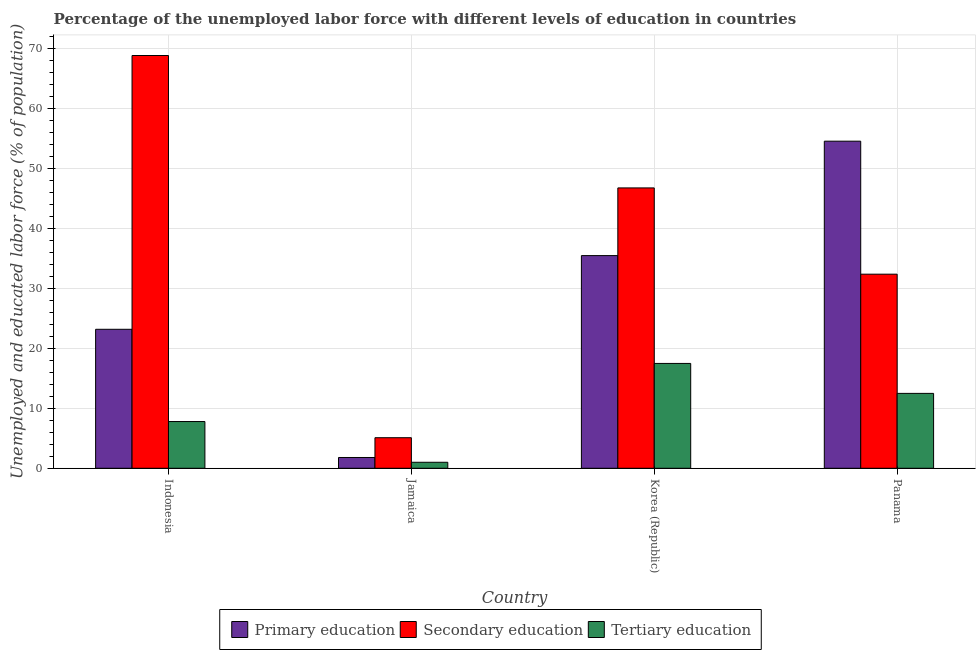How many groups of bars are there?
Offer a very short reply. 4. What is the label of the 2nd group of bars from the left?
Offer a terse response. Jamaica. In how many cases, is the number of bars for a given country not equal to the number of legend labels?
Your answer should be very brief. 0. What is the percentage of labor force who received tertiary education in Panama?
Your answer should be compact. 12.5. Across all countries, what is the minimum percentage of labor force who received primary education?
Offer a terse response. 1.8. In which country was the percentage of labor force who received primary education minimum?
Your response must be concise. Jamaica. What is the total percentage of labor force who received primary education in the graph?
Offer a terse response. 115.1. What is the difference between the percentage of labor force who received secondary education in Jamaica and that in Korea (Republic)?
Provide a succinct answer. -41.7. What is the difference between the percentage of labor force who received tertiary education in Indonesia and the percentage of labor force who received primary education in Panama?
Keep it short and to the point. -46.8. What is the average percentage of labor force who received primary education per country?
Offer a very short reply. 28.77. What is the difference between the percentage of labor force who received secondary education and percentage of labor force who received primary education in Korea (Republic)?
Provide a succinct answer. 11.3. What is the ratio of the percentage of labor force who received secondary education in Indonesia to that in Korea (Republic)?
Make the answer very short. 1.47. Is the percentage of labor force who received primary education in Jamaica less than that in Panama?
Your answer should be very brief. Yes. What is the difference between the highest and the second highest percentage of labor force who received secondary education?
Make the answer very short. 22.1. What is the difference between the highest and the lowest percentage of labor force who received primary education?
Make the answer very short. 52.8. In how many countries, is the percentage of labor force who received secondary education greater than the average percentage of labor force who received secondary education taken over all countries?
Your answer should be compact. 2. What does the 3rd bar from the left in Korea (Republic) represents?
Your response must be concise. Tertiary education. What does the 1st bar from the right in Jamaica represents?
Ensure brevity in your answer.  Tertiary education. Is it the case that in every country, the sum of the percentage of labor force who received primary education and percentage of labor force who received secondary education is greater than the percentage of labor force who received tertiary education?
Keep it short and to the point. Yes. Are all the bars in the graph horizontal?
Offer a very short reply. No. How many countries are there in the graph?
Offer a very short reply. 4. What is the difference between two consecutive major ticks on the Y-axis?
Provide a succinct answer. 10. Are the values on the major ticks of Y-axis written in scientific E-notation?
Offer a terse response. No. Does the graph contain any zero values?
Offer a terse response. No. What is the title of the graph?
Offer a terse response. Percentage of the unemployed labor force with different levels of education in countries. What is the label or title of the Y-axis?
Your answer should be compact. Unemployed and educated labor force (% of population). What is the Unemployed and educated labor force (% of population) of Primary education in Indonesia?
Your response must be concise. 23.2. What is the Unemployed and educated labor force (% of population) in Secondary education in Indonesia?
Provide a short and direct response. 68.9. What is the Unemployed and educated labor force (% of population) of Tertiary education in Indonesia?
Keep it short and to the point. 7.8. What is the Unemployed and educated labor force (% of population) of Primary education in Jamaica?
Offer a terse response. 1.8. What is the Unemployed and educated labor force (% of population) of Secondary education in Jamaica?
Your response must be concise. 5.1. What is the Unemployed and educated labor force (% of population) of Tertiary education in Jamaica?
Your answer should be compact. 1. What is the Unemployed and educated labor force (% of population) in Primary education in Korea (Republic)?
Ensure brevity in your answer.  35.5. What is the Unemployed and educated labor force (% of population) in Secondary education in Korea (Republic)?
Provide a short and direct response. 46.8. What is the Unemployed and educated labor force (% of population) in Tertiary education in Korea (Republic)?
Offer a terse response. 17.5. What is the Unemployed and educated labor force (% of population) of Primary education in Panama?
Your answer should be compact. 54.6. What is the Unemployed and educated labor force (% of population) in Secondary education in Panama?
Provide a short and direct response. 32.4. What is the Unemployed and educated labor force (% of population) of Tertiary education in Panama?
Provide a succinct answer. 12.5. Across all countries, what is the maximum Unemployed and educated labor force (% of population) of Primary education?
Provide a succinct answer. 54.6. Across all countries, what is the maximum Unemployed and educated labor force (% of population) of Secondary education?
Make the answer very short. 68.9. Across all countries, what is the maximum Unemployed and educated labor force (% of population) in Tertiary education?
Offer a very short reply. 17.5. Across all countries, what is the minimum Unemployed and educated labor force (% of population) in Primary education?
Ensure brevity in your answer.  1.8. Across all countries, what is the minimum Unemployed and educated labor force (% of population) in Secondary education?
Offer a terse response. 5.1. Across all countries, what is the minimum Unemployed and educated labor force (% of population) in Tertiary education?
Your response must be concise. 1. What is the total Unemployed and educated labor force (% of population) of Primary education in the graph?
Ensure brevity in your answer.  115.1. What is the total Unemployed and educated labor force (% of population) in Secondary education in the graph?
Offer a very short reply. 153.2. What is the total Unemployed and educated labor force (% of population) in Tertiary education in the graph?
Your answer should be compact. 38.8. What is the difference between the Unemployed and educated labor force (% of population) in Primary education in Indonesia and that in Jamaica?
Ensure brevity in your answer.  21.4. What is the difference between the Unemployed and educated labor force (% of population) of Secondary education in Indonesia and that in Jamaica?
Give a very brief answer. 63.8. What is the difference between the Unemployed and educated labor force (% of population) of Primary education in Indonesia and that in Korea (Republic)?
Provide a short and direct response. -12.3. What is the difference between the Unemployed and educated labor force (% of population) in Secondary education in Indonesia and that in Korea (Republic)?
Your response must be concise. 22.1. What is the difference between the Unemployed and educated labor force (% of population) in Tertiary education in Indonesia and that in Korea (Republic)?
Provide a succinct answer. -9.7. What is the difference between the Unemployed and educated labor force (% of population) of Primary education in Indonesia and that in Panama?
Provide a short and direct response. -31.4. What is the difference between the Unemployed and educated labor force (% of population) in Secondary education in Indonesia and that in Panama?
Give a very brief answer. 36.5. What is the difference between the Unemployed and educated labor force (% of population) of Primary education in Jamaica and that in Korea (Republic)?
Provide a short and direct response. -33.7. What is the difference between the Unemployed and educated labor force (% of population) in Secondary education in Jamaica and that in Korea (Republic)?
Provide a succinct answer. -41.7. What is the difference between the Unemployed and educated labor force (% of population) of Tertiary education in Jamaica and that in Korea (Republic)?
Give a very brief answer. -16.5. What is the difference between the Unemployed and educated labor force (% of population) in Primary education in Jamaica and that in Panama?
Your answer should be compact. -52.8. What is the difference between the Unemployed and educated labor force (% of population) in Secondary education in Jamaica and that in Panama?
Make the answer very short. -27.3. What is the difference between the Unemployed and educated labor force (% of population) of Primary education in Korea (Republic) and that in Panama?
Keep it short and to the point. -19.1. What is the difference between the Unemployed and educated labor force (% of population) in Tertiary education in Korea (Republic) and that in Panama?
Provide a short and direct response. 5. What is the difference between the Unemployed and educated labor force (% of population) in Primary education in Indonesia and the Unemployed and educated labor force (% of population) in Secondary education in Jamaica?
Your response must be concise. 18.1. What is the difference between the Unemployed and educated labor force (% of population) in Secondary education in Indonesia and the Unemployed and educated labor force (% of population) in Tertiary education in Jamaica?
Give a very brief answer. 67.9. What is the difference between the Unemployed and educated labor force (% of population) in Primary education in Indonesia and the Unemployed and educated labor force (% of population) in Secondary education in Korea (Republic)?
Give a very brief answer. -23.6. What is the difference between the Unemployed and educated labor force (% of population) in Secondary education in Indonesia and the Unemployed and educated labor force (% of population) in Tertiary education in Korea (Republic)?
Provide a short and direct response. 51.4. What is the difference between the Unemployed and educated labor force (% of population) in Primary education in Indonesia and the Unemployed and educated labor force (% of population) in Secondary education in Panama?
Ensure brevity in your answer.  -9.2. What is the difference between the Unemployed and educated labor force (% of population) of Primary education in Indonesia and the Unemployed and educated labor force (% of population) of Tertiary education in Panama?
Keep it short and to the point. 10.7. What is the difference between the Unemployed and educated labor force (% of population) of Secondary education in Indonesia and the Unemployed and educated labor force (% of population) of Tertiary education in Panama?
Ensure brevity in your answer.  56.4. What is the difference between the Unemployed and educated labor force (% of population) of Primary education in Jamaica and the Unemployed and educated labor force (% of population) of Secondary education in Korea (Republic)?
Your response must be concise. -45. What is the difference between the Unemployed and educated labor force (% of population) of Primary education in Jamaica and the Unemployed and educated labor force (% of population) of Tertiary education in Korea (Republic)?
Provide a succinct answer. -15.7. What is the difference between the Unemployed and educated labor force (% of population) in Primary education in Jamaica and the Unemployed and educated labor force (% of population) in Secondary education in Panama?
Make the answer very short. -30.6. What is the difference between the Unemployed and educated labor force (% of population) in Secondary education in Korea (Republic) and the Unemployed and educated labor force (% of population) in Tertiary education in Panama?
Make the answer very short. 34.3. What is the average Unemployed and educated labor force (% of population) in Primary education per country?
Your answer should be compact. 28.77. What is the average Unemployed and educated labor force (% of population) of Secondary education per country?
Your answer should be very brief. 38.3. What is the difference between the Unemployed and educated labor force (% of population) in Primary education and Unemployed and educated labor force (% of population) in Secondary education in Indonesia?
Your answer should be compact. -45.7. What is the difference between the Unemployed and educated labor force (% of population) in Primary education and Unemployed and educated labor force (% of population) in Tertiary education in Indonesia?
Offer a terse response. 15.4. What is the difference between the Unemployed and educated labor force (% of population) in Secondary education and Unemployed and educated labor force (% of population) in Tertiary education in Indonesia?
Keep it short and to the point. 61.1. What is the difference between the Unemployed and educated labor force (% of population) of Primary education and Unemployed and educated labor force (% of population) of Secondary education in Jamaica?
Make the answer very short. -3.3. What is the difference between the Unemployed and educated labor force (% of population) in Primary education and Unemployed and educated labor force (% of population) in Tertiary education in Jamaica?
Your response must be concise. 0.8. What is the difference between the Unemployed and educated labor force (% of population) of Secondary education and Unemployed and educated labor force (% of population) of Tertiary education in Jamaica?
Give a very brief answer. 4.1. What is the difference between the Unemployed and educated labor force (% of population) of Primary education and Unemployed and educated labor force (% of population) of Secondary education in Korea (Republic)?
Ensure brevity in your answer.  -11.3. What is the difference between the Unemployed and educated labor force (% of population) of Primary education and Unemployed and educated labor force (% of population) of Tertiary education in Korea (Republic)?
Your answer should be very brief. 18. What is the difference between the Unemployed and educated labor force (% of population) in Secondary education and Unemployed and educated labor force (% of population) in Tertiary education in Korea (Republic)?
Keep it short and to the point. 29.3. What is the difference between the Unemployed and educated labor force (% of population) in Primary education and Unemployed and educated labor force (% of population) in Tertiary education in Panama?
Your response must be concise. 42.1. What is the ratio of the Unemployed and educated labor force (% of population) of Primary education in Indonesia to that in Jamaica?
Make the answer very short. 12.89. What is the ratio of the Unemployed and educated labor force (% of population) in Secondary education in Indonesia to that in Jamaica?
Your answer should be very brief. 13.51. What is the ratio of the Unemployed and educated labor force (% of population) of Primary education in Indonesia to that in Korea (Republic)?
Your answer should be very brief. 0.65. What is the ratio of the Unemployed and educated labor force (% of population) of Secondary education in Indonesia to that in Korea (Republic)?
Offer a terse response. 1.47. What is the ratio of the Unemployed and educated labor force (% of population) of Tertiary education in Indonesia to that in Korea (Republic)?
Provide a short and direct response. 0.45. What is the ratio of the Unemployed and educated labor force (% of population) of Primary education in Indonesia to that in Panama?
Your answer should be very brief. 0.42. What is the ratio of the Unemployed and educated labor force (% of population) in Secondary education in Indonesia to that in Panama?
Provide a succinct answer. 2.13. What is the ratio of the Unemployed and educated labor force (% of population) of Tertiary education in Indonesia to that in Panama?
Make the answer very short. 0.62. What is the ratio of the Unemployed and educated labor force (% of population) of Primary education in Jamaica to that in Korea (Republic)?
Offer a terse response. 0.05. What is the ratio of the Unemployed and educated labor force (% of population) of Secondary education in Jamaica to that in Korea (Republic)?
Make the answer very short. 0.11. What is the ratio of the Unemployed and educated labor force (% of population) of Tertiary education in Jamaica to that in Korea (Republic)?
Offer a terse response. 0.06. What is the ratio of the Unemployed and educated labor force (% of population) of Primary education in Jamaica to that in Panama?
Provide a succinct answer. 0.03. What is the ratio of the Unemployed and educated labor force (% of population) in Secondary education in Jamaica to that in Panama?
Offer a terse response. 0.16. What is the ratio of the Unemployed and educated labor force (% of population) of Tertiary education in Jamaica to that in Panama?
Provide a succinct answer. 0.08. What is the ratio of the Unemployed and educated labor force (% of population) of Primary education in Korea (Republic) to that in Panama?
Make the answer very short. 0.65. What is the ratio of the Unemployed and educated labor force (% of population) in Secondary education in Korea (Republic) to that in Panama?
Make the answer very short. 1.44. What is the ratio of the Unemployed and educated labor force (% of population) of Tertiary education in Korea (Republic) to that in Panama?
Your answer should be very brief. 1.4. What is the difference between the highest and the second highest Unemployed and educated labor force (% of population) in Primary education?
Keep it short and to the point. 19.1. What is the difference between the highest and the second highest Unemployed and educated labor force (% of population) of Secondary education?
Your answer should be very brief. 22.1. What is the difference between the highest and the second highest Unemployed and educated labor force (% of population) of Tertiary education?
Give a very brief answer. 5. What is the difference between the highest and the lowest Unemployed and educated labor force (% of population) in Primary education?
Your answer should be compact. 52.8. What is the difference between the highest and the lowest Unemployed and educated labor force (% of population) in Secondary education?
Give a very brief answer. 63.8. 